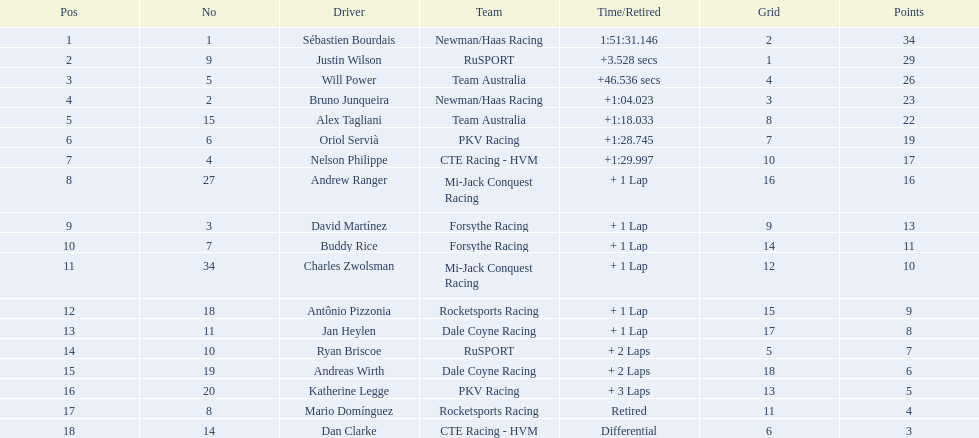Which nation is depicted by the highest number of drivers? United Kingdom. 